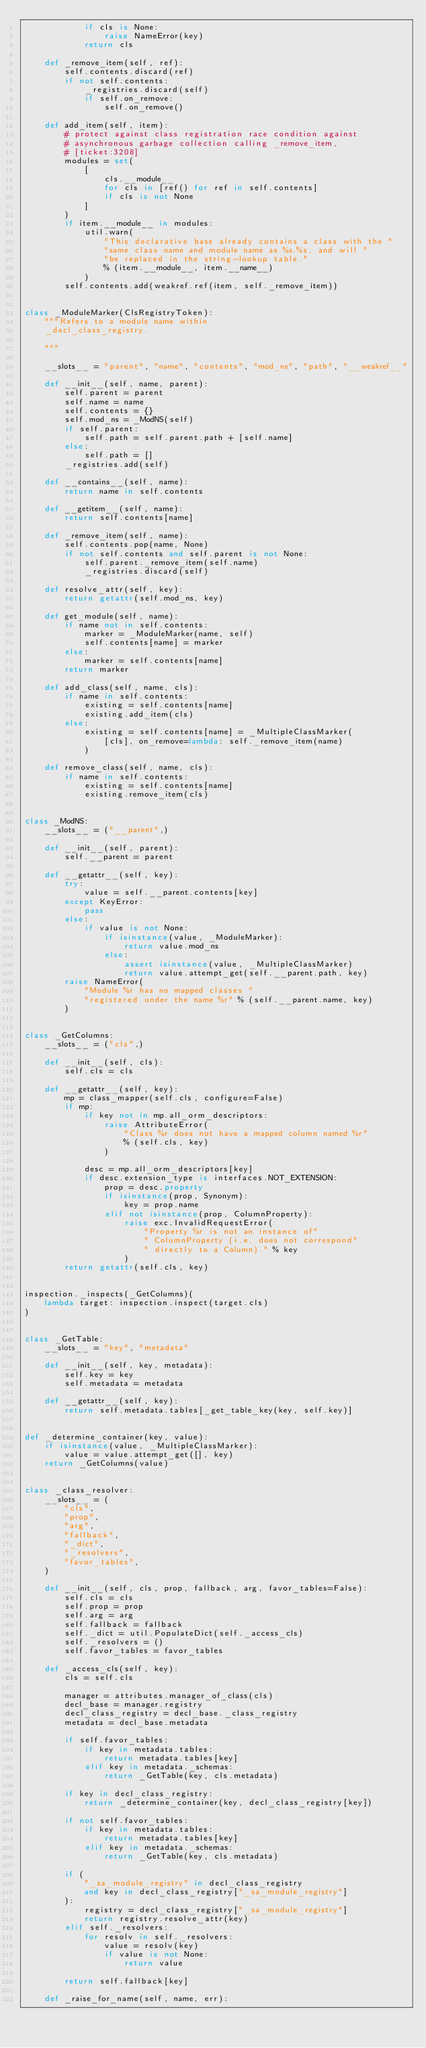<code> <loc_0><loc_0><loc_500><loc_500><_Python_>            if cls is None:
                raise NameError(key)
            return cls

    def _remove_item(self, ref):
        self.contents.discard(ref)
        if not self.contents:
            _registries.discard(self)
            if self.on_remove:
                self.on_remove()

    def add_item(self, item):
        # protect against class registration race condition against
        # asynchronous garbage collection calling _remove_item,
        # [ticket:3208]
        modules = set(
            [
                cls.__module__
                for cls in [ref() for ref in self.contents]
                if cls is not None
            ]
        )
        if item.__module__ in modules:
            util.warn(
                "This declarative base already contains a class with the "
                "same class name and module name as %s.%s, and will "
                "be replaced in the string-lookup table."
                % (item.__module__, item.__name__)
            )
        self.contents.add(weakref.ref(item, self._remove_item))


class _ModuleMarker(ClsRegistryToken):
    """Refers to a module name within
    _decl_class_registry.

    """

    __slots__ = "parent", "name", "contents", "mod_ns", "path", "__weakref__"

    def __init__(self, name, parent):
        self.parent = parent
        self.name = name
        self.contents = {}
        self.mod_ns = _ModNS(self)
        if self.parent:
            self.path = self.parent.path + [self.name]
        else:
            self.path = []
        _registries.add(self)

    def __contains__(self, name):
        return name in self.contents

    def __getitem__(self, name):
        return self.contents[name]

    def _remove_item(self, name):
        self.contents.pop(name, None)
        if not self.contents and self.parent is not None:
            self.parent._remove_item(self.name)
            _registries.discard(self)

    def resolve_attr(self, key):
        return getattr(self.mod_ns, key)

    def get_module(self, name):
        if name not in self.contents:
            marker = _ModuleMarker(name, self)
            self.contents[name] = marker
        else:
            marker = self.contents[name]
        return marker

    def add_class(self, name, cls):
        if name in self.contents:
            existing = self.contents[name]
            existing.add_item(cls)
        else:
            existing = self.contents[name] = _MultipleClassMarker(
                [cls], on_remove=lambda: self._remove_item(name)
            )

    def remove_class(self, name, cls):
        if name in self.contents:
            existing = self.contents[name]
            existing.remove_item(cls)


class _ModNS:
    __slots__ = ("__parent",)

    def __init__(self, parent):
        self.__parent = parent

    def __getattr__(self, key):
        try:
            value = self.__parent.contents[key]
        except KeyError:
            pass
        else:
            if value is not None:
                if isinstance(value, _ModuleMarker):
                    return value.mod_ns
                else:
                    assert isinstance(value, _MultipleClassMarker)
                    return value.attempt_get(self.__parent.path, key)
        raise NameError(
            "Module %r has no mapped classes "
            "registered under the name %r" % (self.__parent.name, key)
        )


class _GetColumns:
    __slots__ = ("cls",)

    def __init__(self, cls):
        self.cls = cls

    def __getattr__(self, key):
        mp = class_mapper(self.cls, configure=False)
        if mp:
            if key not in mp.all_orm_descriptors:
                raise AttributeError(
                    "Class %r does not have a mapped column named %r"
                    % (self.cls, key)
                )

            desc = mp.all_orm_descriptors[key]
            if desc.extension_type is interfaces.NOT_EXTENSION:
                prop = desc.property
                if isinstance(prop, Synonym):
                    key = prop.name
                elif not isinstance(prop, ColumnProperty):
                    raise exc.InvalidRequestError(
                        "Property %r is not an instance of"
                        " ColumnProperty (i.e. does not correspond"
                        " directly to a Column)." % key
                    )
        return getattr(self.cls, key)


inspection._inspects(_GetColumns)(
    lambda target: inspection.inspect(target.cls)
)


class _GetTable:
    __slots__ = "key", "metadata"

    def __init__(self, key, metadata):
        self.key = key
        self.metadata = metadata

    def __getattr__(self, key):
        return self.metadata.tables[_get_table_key(key, self.key)]


def _determine_container(key, value):
    if isinstance(value, _MultipleClassMarker):
        value = value.attempt_get([], key)
    return _GetColumns(value)


class _class_resolver:
    __slots__ = (
        "cls",
        "prop",
        "arg",
        "fallback",
        "_dict",
        "_resolvers",
        "favor_tables",
    )

    def __init__(self, cls, prop, fallback, arg, favor_tables=False):
        self.cls = cls
        self.prop = prop
        self.arg = arg
        self.fallback = fallback
        self._dict = util.PopulateDict(self._access_cls)
        self._resolvers = ()
        self.favor_tables = favor_tables

    def _access_cls(self, key):
        cls = self.cls

        manager = attributes.manager_of_class(cls)
        decl_base = manager.registry
        decl_class_registry = decl_base._class_registry
        metadata = decl_base.metadata

        if self.favor_tables:
            if key in metadata.tables:
                return metadata.tables[key]
            elif key in metadata._schemas:
                return _GetTable(key, cls.metadata)

        if key in decl_class_registry:
            return _determine_container(key, decl_class_registry[key])

        if not self.favor_tables:
            if key in metadata.tables:
                return metadata.tables[key]
            elif key in metadata._schemas:
                return _GetTable(key, cls.metadata)

        if (
            "_sa_module_registry" in decl_class_registry
            and key in decl_class_registry["_sa_module_registry"]
        ):
            registry = decl_class_registry["_sa_module_registry"]
            return registry.resolve_attr(key)
        elif self._resolvers:
            for resolv in self._resolvers:
                value = resolv(key)
                if value is not None:
                    return value

        return self.fallback[key]

    def _raise_for_name(self, name, err):</code> 